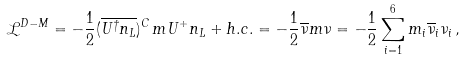Convert formula to latex. <formula><loc_0><loc_0><loc_500><loc_500>\mathcal { L } ^ { D - M } = - \frac { 1 } { 2 } ( \overline { U ^ { \dagger } n _ { L } } ) ^ { C } \, m U ^ { + } n _ { L } + h . c . = - \frac { 1 } { 2 } \overline { \nu } m \nu = - \frac { 1 } { 2 } \sum _ { i = 1 } ^ { 6 } m _ { i } \overline { \nu } _ { i } \nu _ { i } \, ,</formula> 